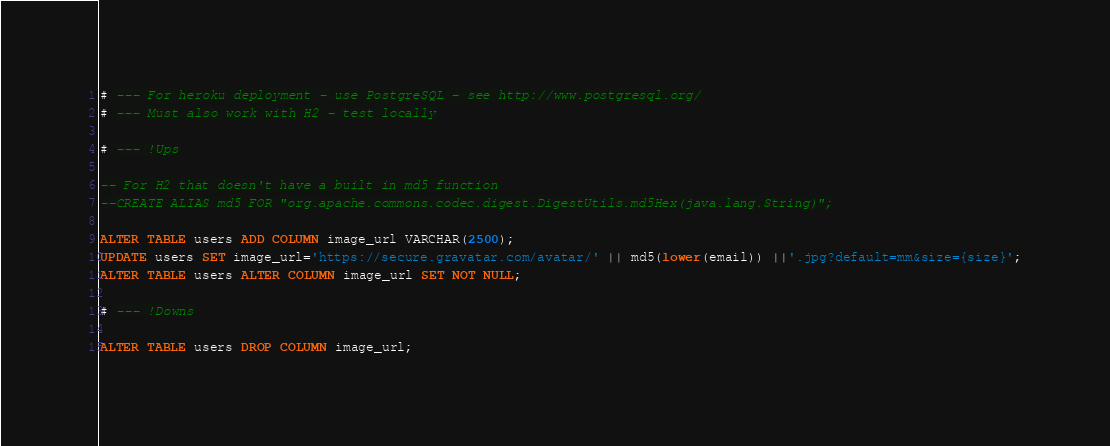Convert code to text. <code><loc_0><loc_0><loc_500><loc_500><_SQL_># --- For heroku deployment - use PostgreSQL - see http://www.postgresql.org/
# --- Must also work with H2 - test locally

# --- !Ups

-- For H2 that doesn't have a built in md5 function
--CREATE ALIAS md5 FOR "org.apache.commons.codec.digest.DigestUtils.md5Hex(java.lang.String)";

ALTER TABLE users ADD COLUMN image_url VARCHAR(2500);
UPDATE users SET image_url='https://secure.gravatar.com/avatar/' || md5(lower(email)) ||'.jpg?default=mm&size={size}';
ALTER TABLE users ALTER COLUMN image_url SET NOT NULL;

# --- !Downs

ALTER TABLE users DROP COLUMN image_url;
</code> 